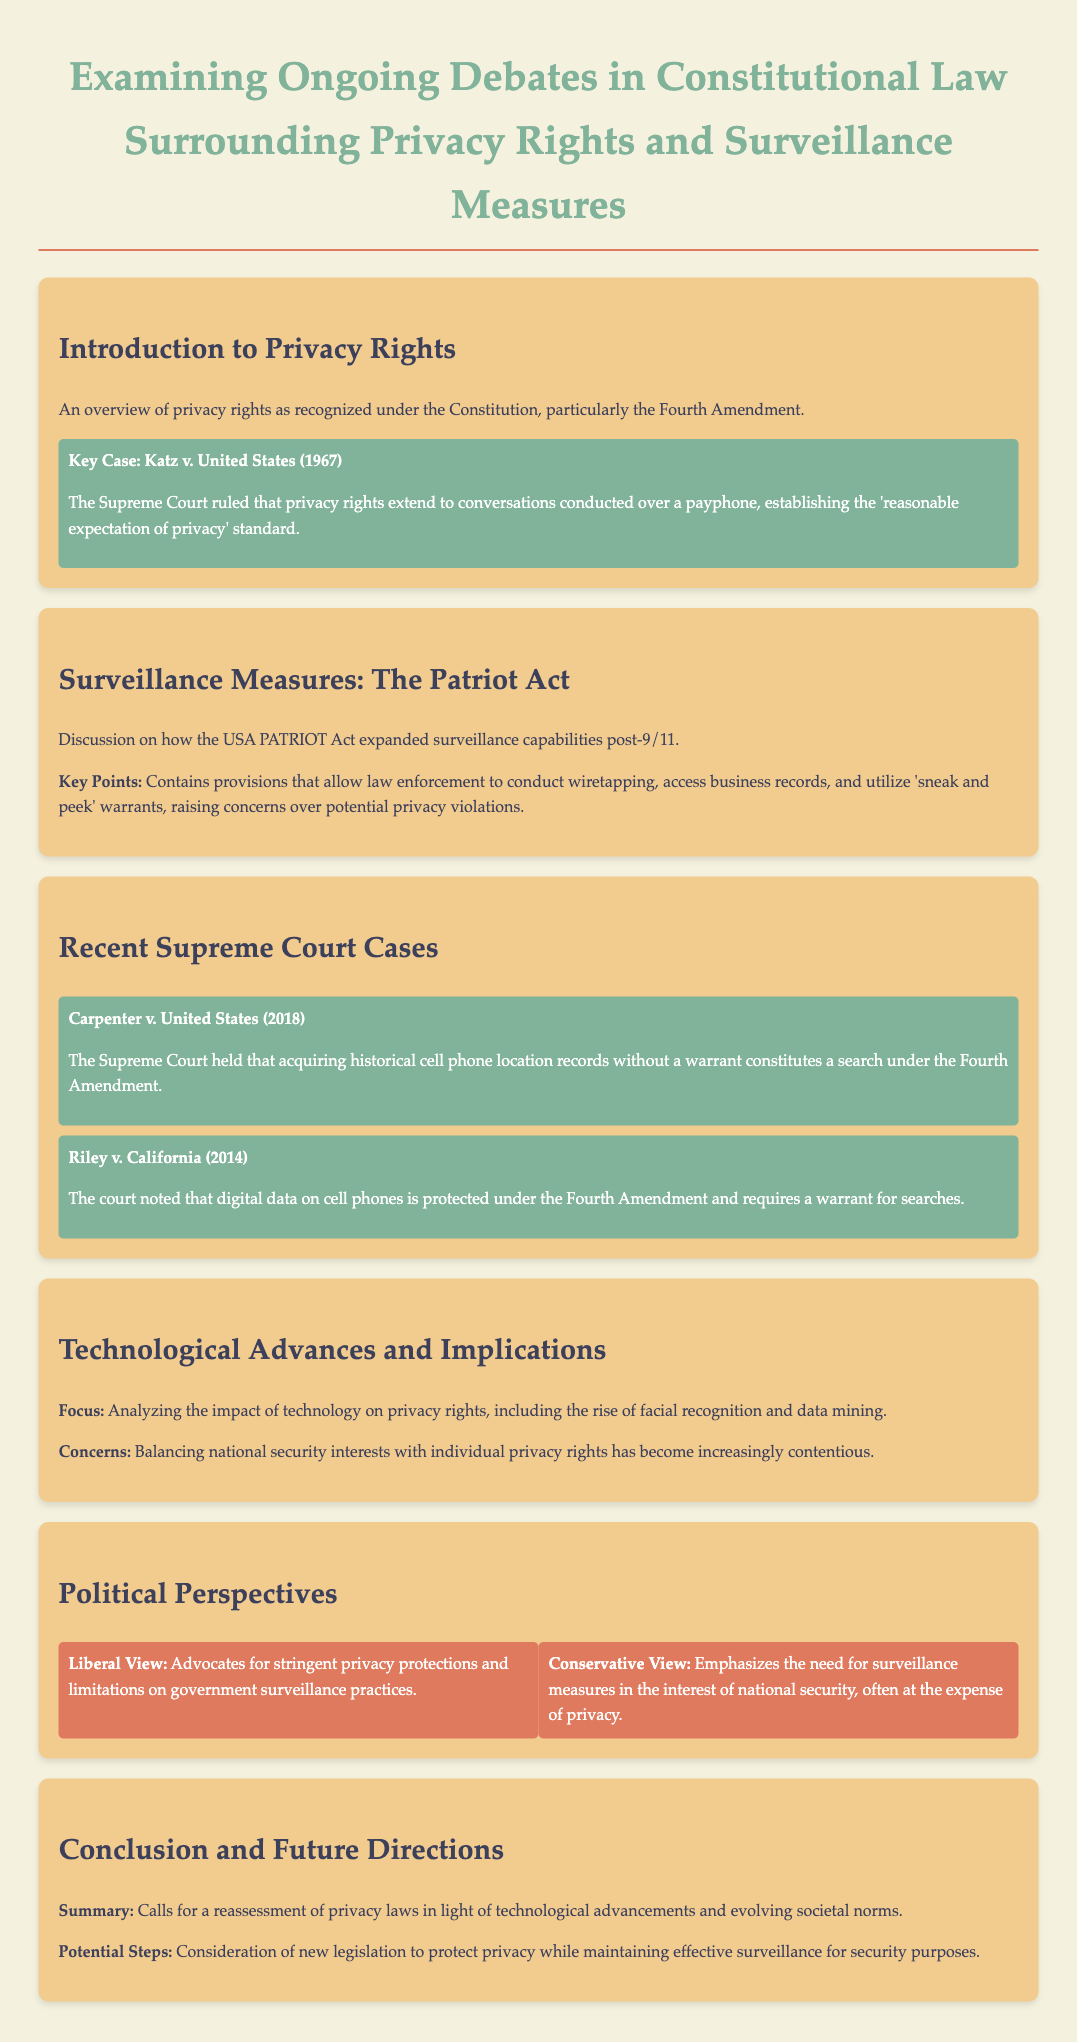What is the title of the document? The title is prominently displayed at the top of the document, summarizing its content.
Answer: Examining Ongoing Debates in Constitutional Law Surrounding Privacy Rights and Surveillance Measures What key case is associated with privacy rights in the introduction? The document explicitly highlights a key case in privacy rights legislation under the Fourth Amendment.
Answer: Katz v. United States (1967) What year was the Carpenter v. United States case decided? The document provides the date of the decision for this significant Supreme Court case regarding privacy rights.
Answer: 2018 What does the USA PATRIOT Act allow law enforcement to do? The document lists provisions within the Act that enhance surveillance capabilities.
Answer: Conduct wiretapping What is a significant concern raised about surveillance measures in the document? The text discusses the implications of surveillance laws and their impact on individual rights.
Answer: Potential privacy violations What overarching issue is highlighted in the section on technological advances? The document notes the tension between conflicting governmental priorities and individual rights regarding technology.
Answer: Balancing national security interests with individual privacy rights What political perspective emphasizes the need for surveillance measures? The document details different political views on privacy and national security.
Answer: Conservative View What does the document suggest about future directions for privacy laws? The content indicates a need for reassessment in light of newer challenges confronting privacy rights.
Answer: Reassessment of privacy laws What are the two key Supreme Court cases discussed under recent cases? The document summarizes recent legal interpretations of privacy rights through notable court decisions.
Answer: Carpenter v. United States and Riley v. California 